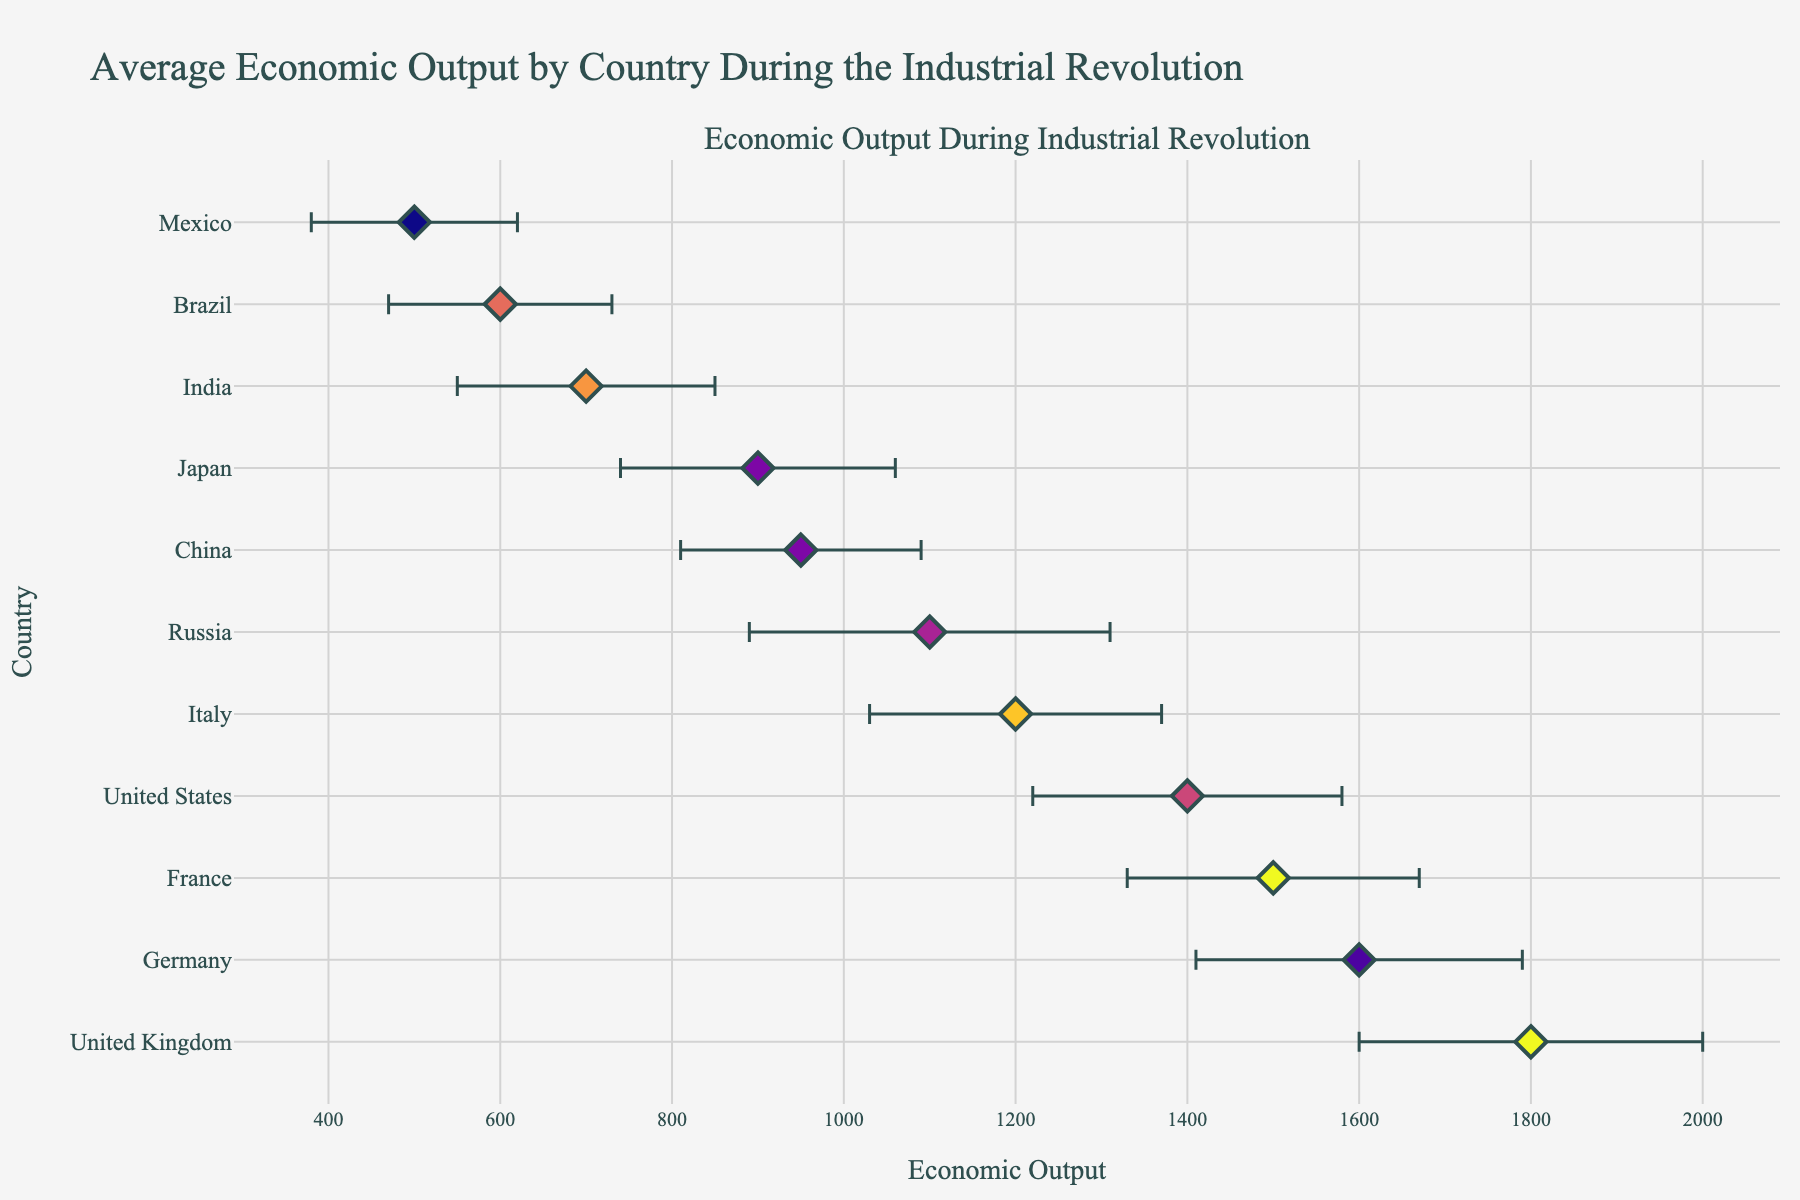What's the title of the plot? The title of the plot is located at the top center of the figure. It reads "Average Economic Output by Country During the Industrial Revolution".
Answer: Average Economic Output by Country During the Industrial Revolution Which country has the highest average economic output? By examining the position of the markers along the x-axis, the country with the furthest right marker represents the highest economic output, which is the United Kingdom with an output of 1800.
Answer: United Kingdom What is the region and economic output of Mexico? Find Mexico on the y-axis and follow the row horizontally to the x-axis. Mexico's economic output is 500 and it belongs to the Central America region.
Answer: Central America, 500 Which country has the largest variability in economic output? Variability is represented by the length of the error bars. The country with the longest error bar is Russia, showing a standard deviation of 210.
Answer: Russia How many countries are shown in the plot? The number of countries is equal to the number of points (markers) visible on the plot. This plot shows 11 countries.
Answer: 11 Compare the average economic output of Germany and Japan. Which one is higher and by how much? Identify Germany and Japan on the y-axis and read their respective average economic outputs from the x-axis. Germany's output is 1600 and Japan's is 900. The difference is 1600 - 900 = 700, with Germany having the higher output.
Answer: Germany, 700 What color and shape indicates the average output value for the East Asia region? The color coding and marker shape for the regions can be deduced by comparing different countries in the same region. East Asia includes Japan and China, both appear in similar colors and diamond markers.
Answer: Specific color, diamond shape Are there any countries from Eastern Europe plotted in the chart? If yes, name them. By looking for regions labeled on the y-axis, Russia, from Eastern Europe, is included in the plot.
Answer: Yes, Russia Which country has an economic output closest to 1000? Check the economic output values plotted on the x-axis and locate the closest to 1000. Japan, with an economic output of 900, is the nearest.
Answer: Japan 